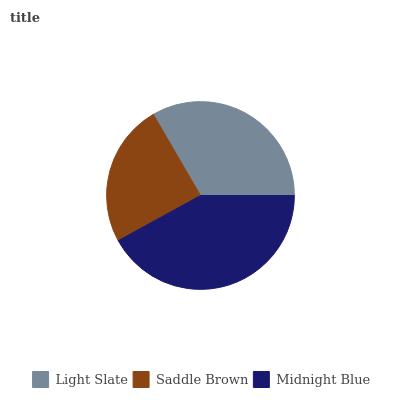Is Saddle Brown the minimum?
Answer yes or no. Yes. Is Midnight Blue the maximum?
Answer yes or no. Yes. Is Midnight Blue the minimum?
Answer yes or no. No. Is Saddle Brown the maximum?
Answer yes or no. No. Is Midnight Blue greater than Saddle Brown?
Answer yes or no. Yes. Is Saddle Brown less than Midnight Blue?
Answer yes or no. Yes. Is Saddle Brown greater than Midnight Blue?
Answer yes or no. No. Is Midnight Blue less than Saddle Brown?
Answer yes or no. No. Is Light Slate the high median?
Answer yes or no. Yes. Is Light Slate the low median?
Answer yes or no. Yes. Is Midnight Blue the high median?
Answer yes or no. No. Is Midnight Blue the low median?
Answer yes or no. No. 